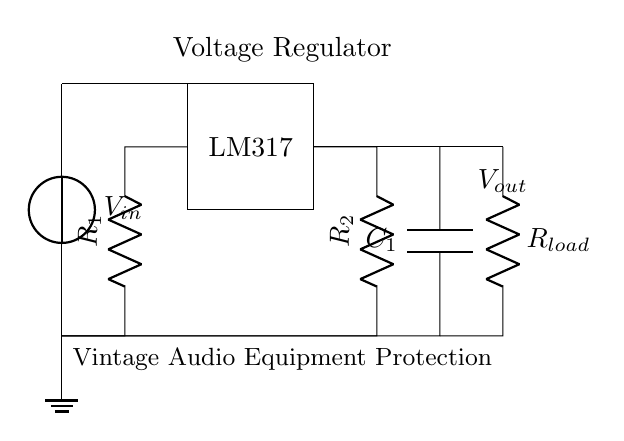What is the input voltage for this circuit? The input voltage is indicated by the voltage source labeled as V_in, which is directly connected to the top of the voltage regulator.
Answer: V_in What component is used as a voltage regulator? The component serving as the voltage regulator is designated as LM317 within the rectangle shown in the circuit diagram.
Answer: LM317 What are the resistor values in this circuit? The resistors labeled R_1 and R_2 can be identified in the circuit; however, their specific numerical values are not provided in the diagram itself.
Answer: R_1 and R_2 What is the purpose of capacitor C_1? The capacitor labeled C_1 is typically used for filtering and stabilizing the output voltage by smoothing any fluctuations, providing a more consistent output.
Answer: Filtering and stabilizing What is connected to the output of this circuit? The output labeled as V_out is connected to a load represented by R_load, indicating that it will supply power to connected devices, in this case, vintage audio equipment.
Answer: R_load How does the LM317 function in this circuit? The LM317 regulates the voltage by adjusting its output based on the difference between the input voltage and the set resistance values from R_1 and R_2, ensuring stable operation of the connected devices.
Answer: Voltage regulation What is the overall application of this circuit? The circuit is designed for protecting vintage audio equipment from power fluctuations, ensuring the equipment receives a consistent voltage, which is crucial for its performance.
Answer: Vintage audio equipment protection 